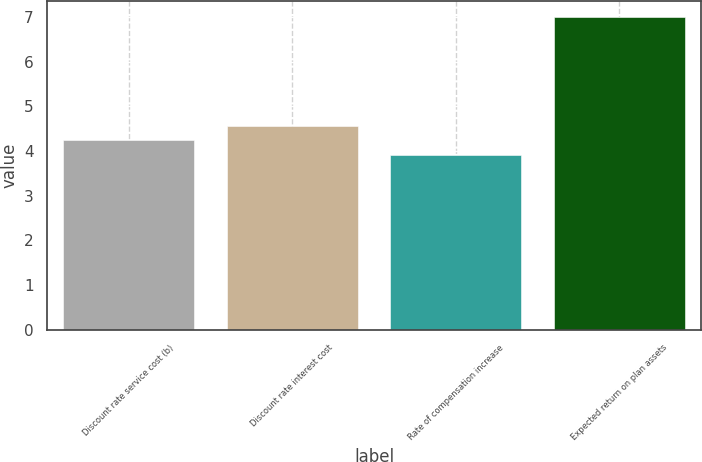Convert chart. <chart><loc_0><loc_0><loc_500><loc_500><bar_chart><fcel>Discount rate service cost (b)<fcel>Discount rate interest cost<fcel>Rate of compensation increase<fcel>Expected return on plan assets<nl><fcel>4.25<fcel>4.56<fcel>3.91<fcel>7<nl></chart> 